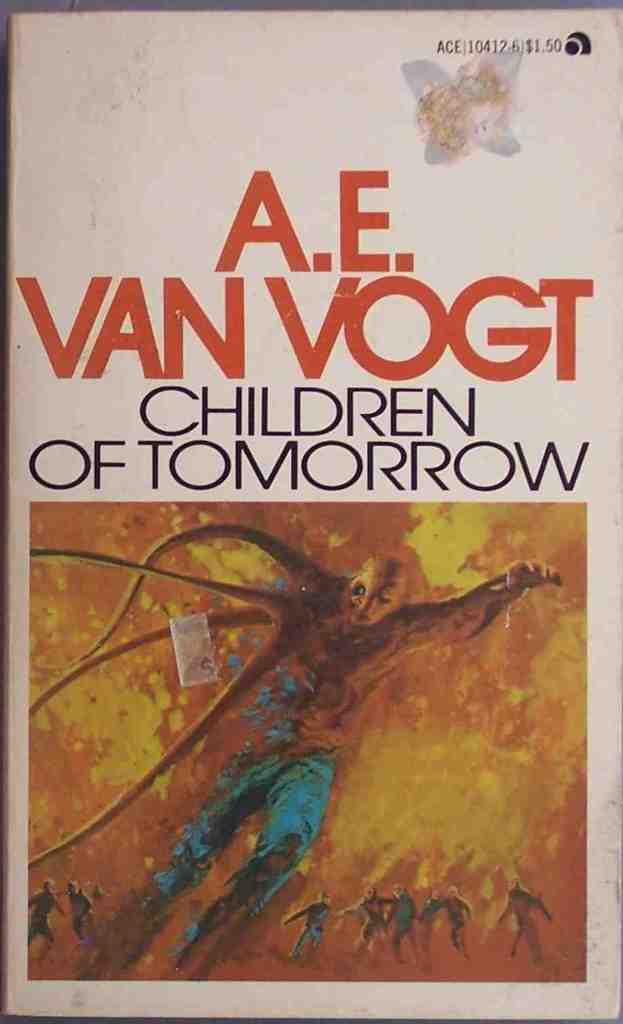<image>
Write a terse but informative summary of the picture. A book titled Children of Tomorrow has a white cover with a picture on it. 